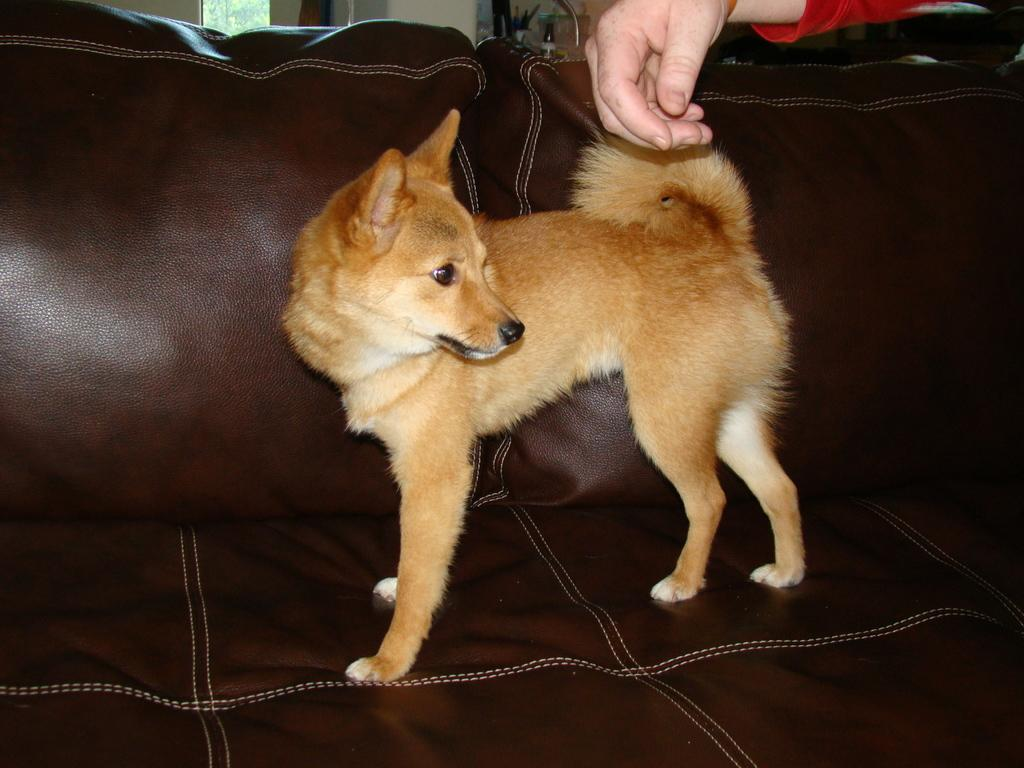What is the main subject of the image? There is a puppy in the image. Where is the puppy located in the image? The puppy is in the center of the image. What is the puppy sitting on? The puppy is on a sofa. Can you tell me how many chances the puppy has to swim in the image? There is no swimming or mention of chances in the image; it simply features a puppy sitting on a sofa. 